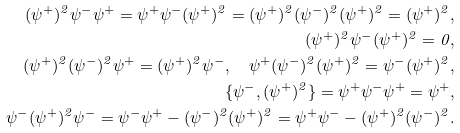<formula> <loc_0><loc_0><loc_500><loc_500>( \psi ^ { + } ) ^ { 2 } \psi ^ { - } \psi ^ { + } = \psi ^ { + } \psi ^ { - } ( \psi ^ { + } ) ^ { 2 } = ( \psi ^ { + } ) ^ { 2 } ( \psi ^ { - } ) ^ { 2 } ( \psi ^ { + } ) ^ { 2 } = ( \psi ^ { + } ) ^ { 2 } , \\ ( \psi ^ { + } ) ^ { 2 } \psi ^ { - } ( \psi ^ { + } ) ^ { 2 } = 0 , \\ ( \psi ^ { + } ) ^ { 2 } ( \psi ^ { - } ) ^ { 2 } \psi ^ { + } = ( \psi ^ { + } ) ^ { 2 } \psi ^ { - } , \quad \psi ^ { + } ( \psi ^ { - } ) ^ { 2 } ( \psi ^ { + } ) ^ { 2 } = \psi ^ { - } ( \psi ^ { + } ) ^ { 2 } , \\ \{ \psi ^ { - } , ( \psi ^ { + } ) ^ { 2 } \} = \psi ^ { + } \psi ^ { - } \psi ^ { + } = \psi ^ { + } , \\ \psi ^ { - } ( \psi ^ { + } ) ^ { 2 } \psi ^ { - } = \psi ^ { - } \psi ^ { + } - ( \psi ^ { - } ) ^ { 2 } ( \psi ^ { + } ) ^ { 2 } = \psi ^ { + } \psi ^ { - } - ( \psi ^ { + } ) ^ { 2 } ( \psi ^ { - } ) ^ { 2 } .</formula> 